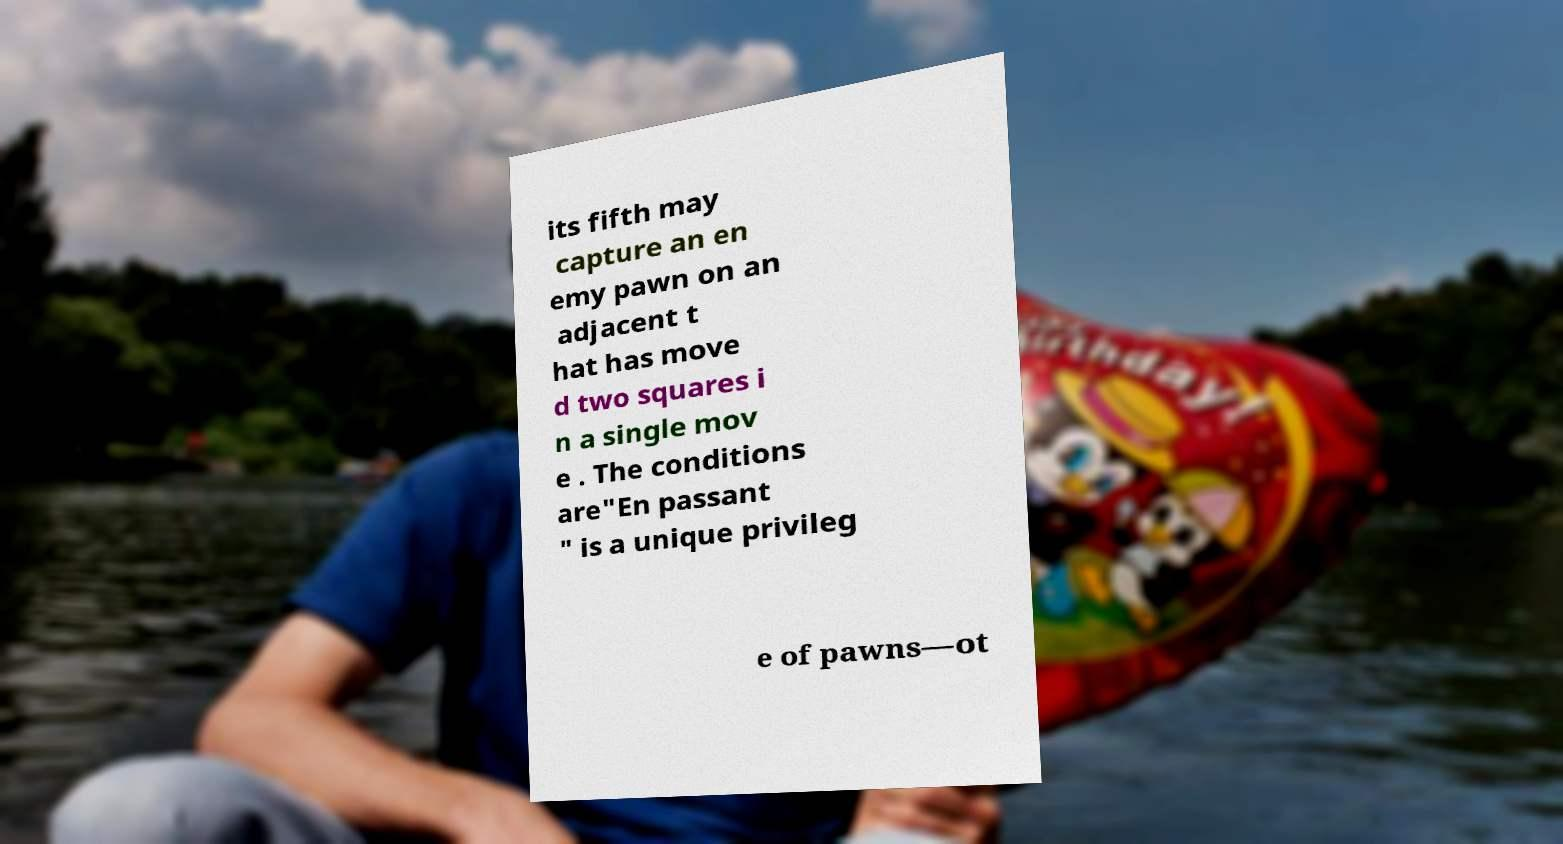I need the written content from this picture converted into text. Can you do that? its fifth may capture an en emy pawn on an adjacent t hat has move d two squares i n a single mov e . The conditions are"En passant " is a unique privileg e of pawns—ot 